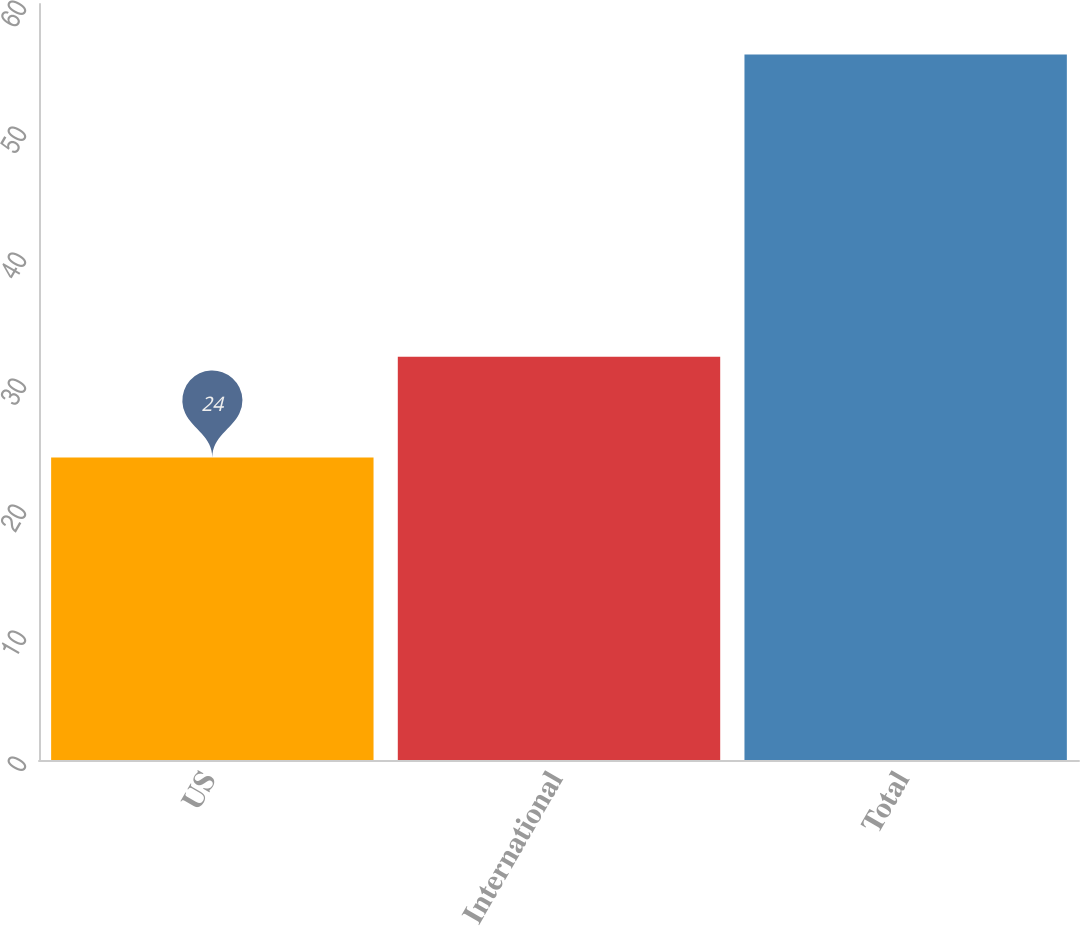Convert chart. <chart><loc_0><loc_0><loc_500><loc_500><bar_chart><fcel>US<fcel>International<fcel>Total<nl><fcel>24<fcel>32<fcel>56<nl></chart> 